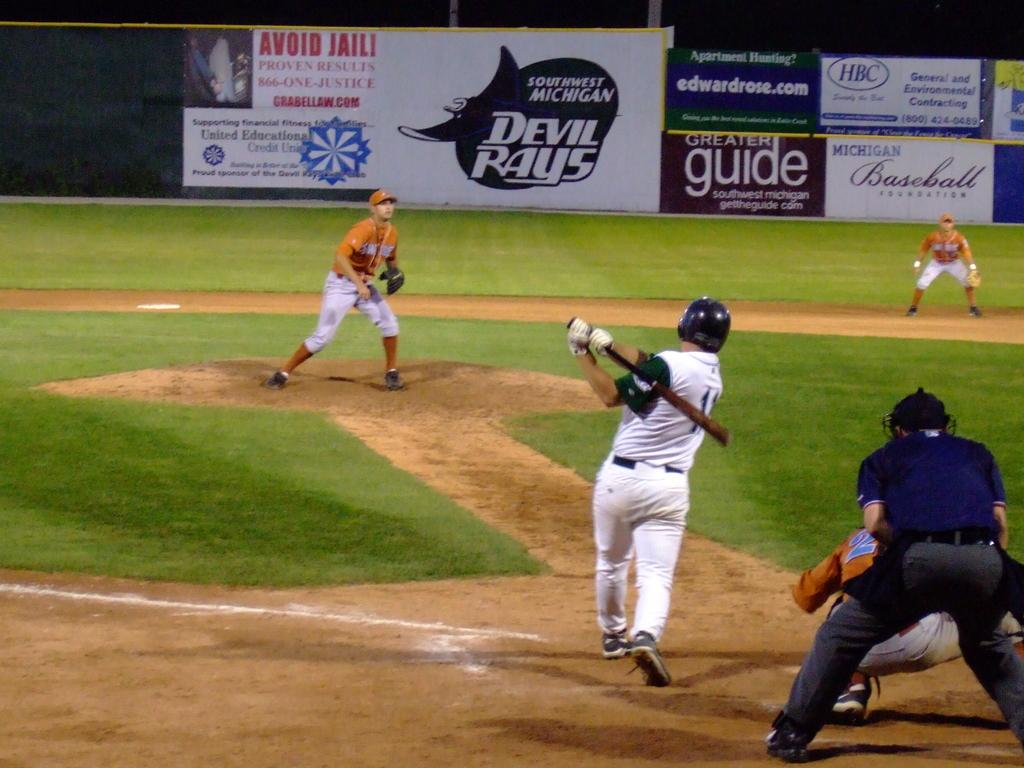<image>
Share a concise interpretation of the image provided. A sign in the backround of a baseball game advertises a website which helps with apartment hunting. 